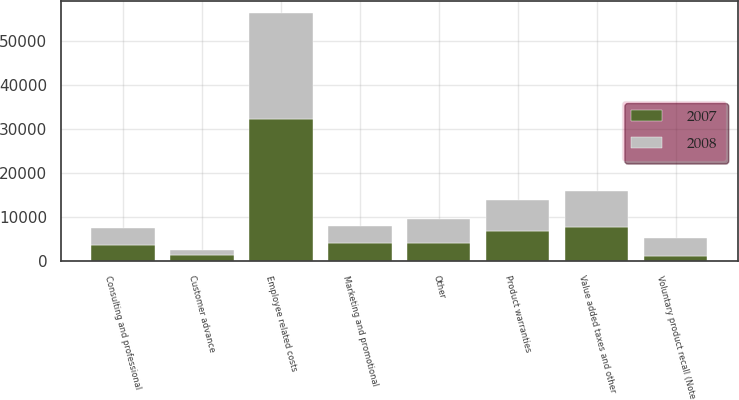Convert chart to OTSL. <chart><loc_0><loc_0><loc_500><loc_500><stacked_bar_chart><ecel><fcel>Product warranties<fcel>Consulting and professional<fcel>Value added taxes and other<fcel>Employee related costs<fcel>Marketing and promotional<fcel>Customer advance<fcel>Voluntary product recall (Note<fcel>Other<nl><fcel>2007<fcel>6863<fcel>3638<fcel>7707<fcel>32405<fcel>4160<fcel>1358<fcel>1028<fcel>4179<nl><fcel>2008<fcel>7040<fcel>3764<fcel>8212<fcel>23942<fcel>3828<fcel>1168<fcel>4179<fcel>5272<nl></chart> 